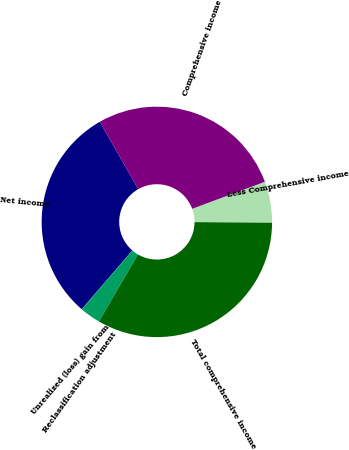Convert chart to OTSL. <chart><loc_0><loc_0><loc_500><loc_500><pie_chart><fcel>Net income<fcel>Unrealized (loss) gain from<fcel>Reclassification adjustment<fcel>Total comprehensive income<fcel>Less Comprehensive income<fcel>Comprehensive income<nl><fcel>30.45%<fcel>0.03%<fcel>2.89%<fcel>33.31%<fcel>5.74%<fcel>27.59%<nl></chart> 